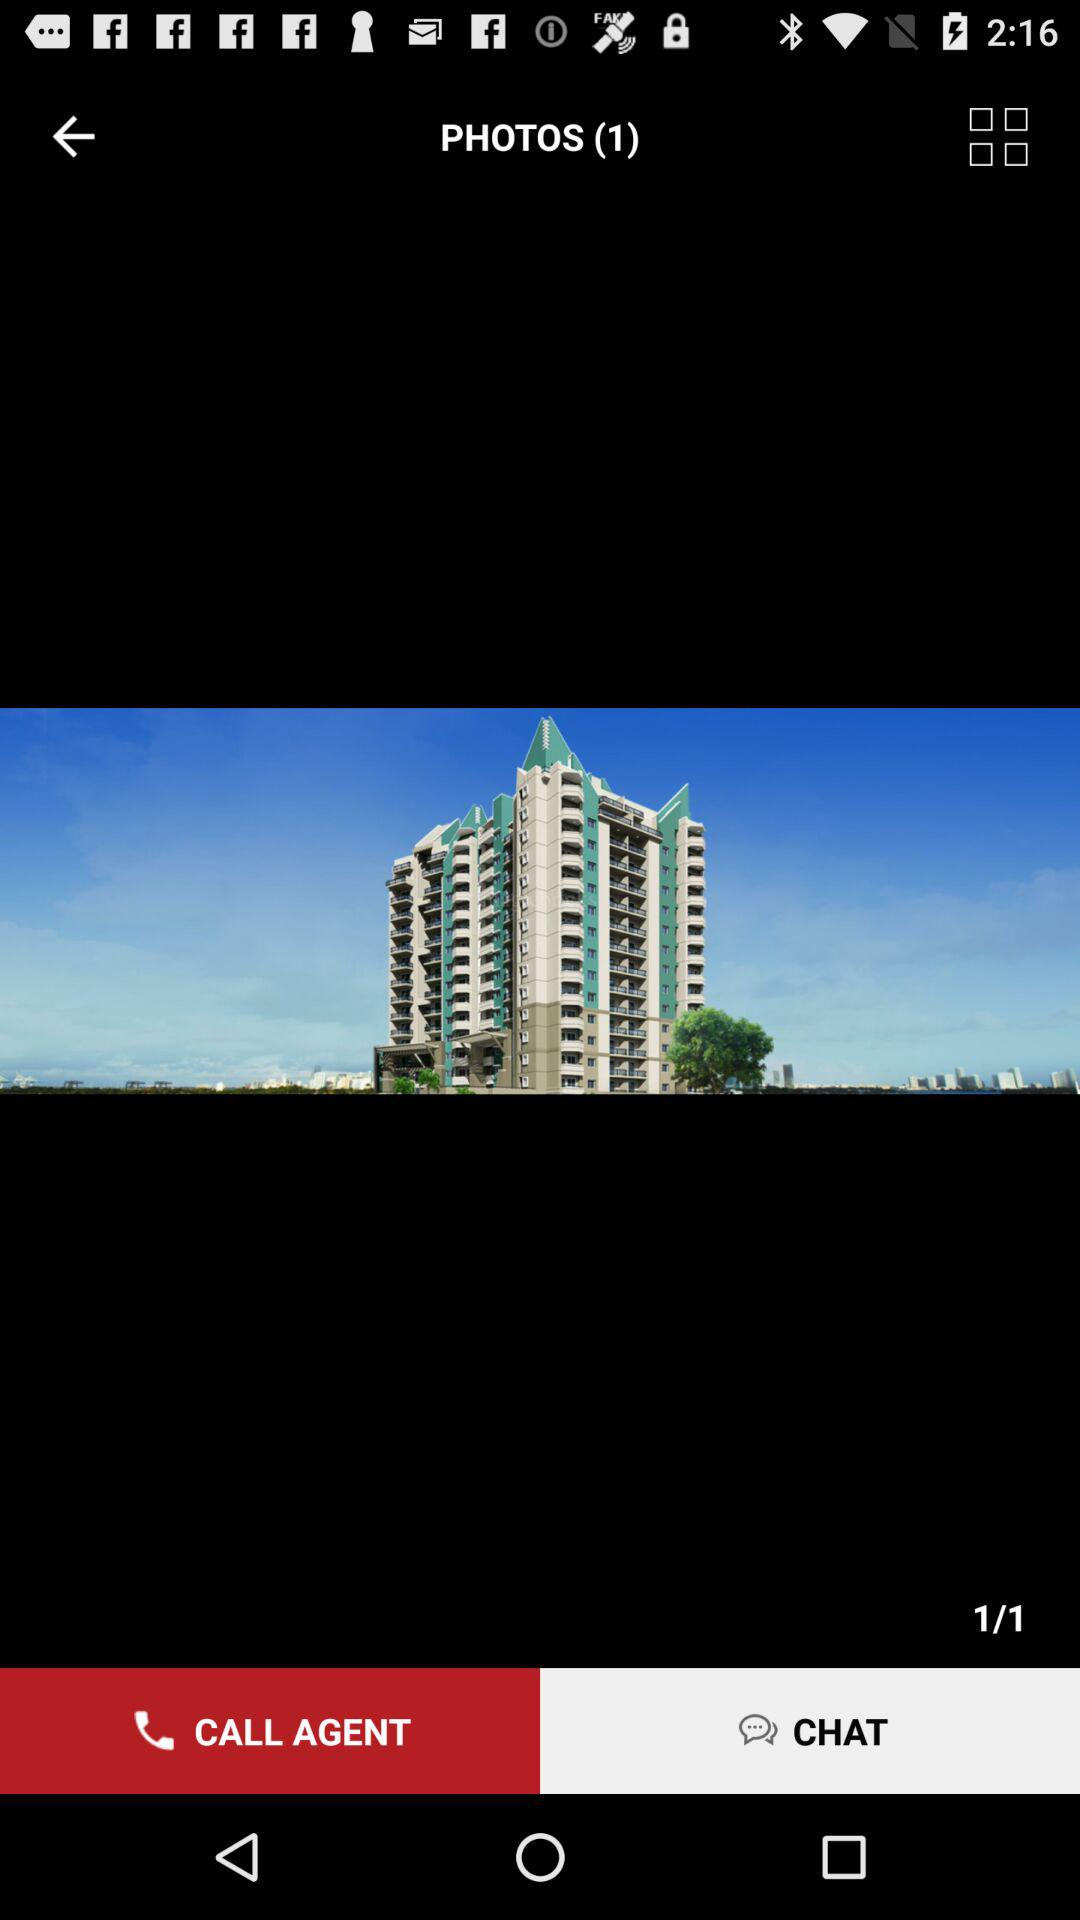What's the total number of photos? The total number of photos is 1. 